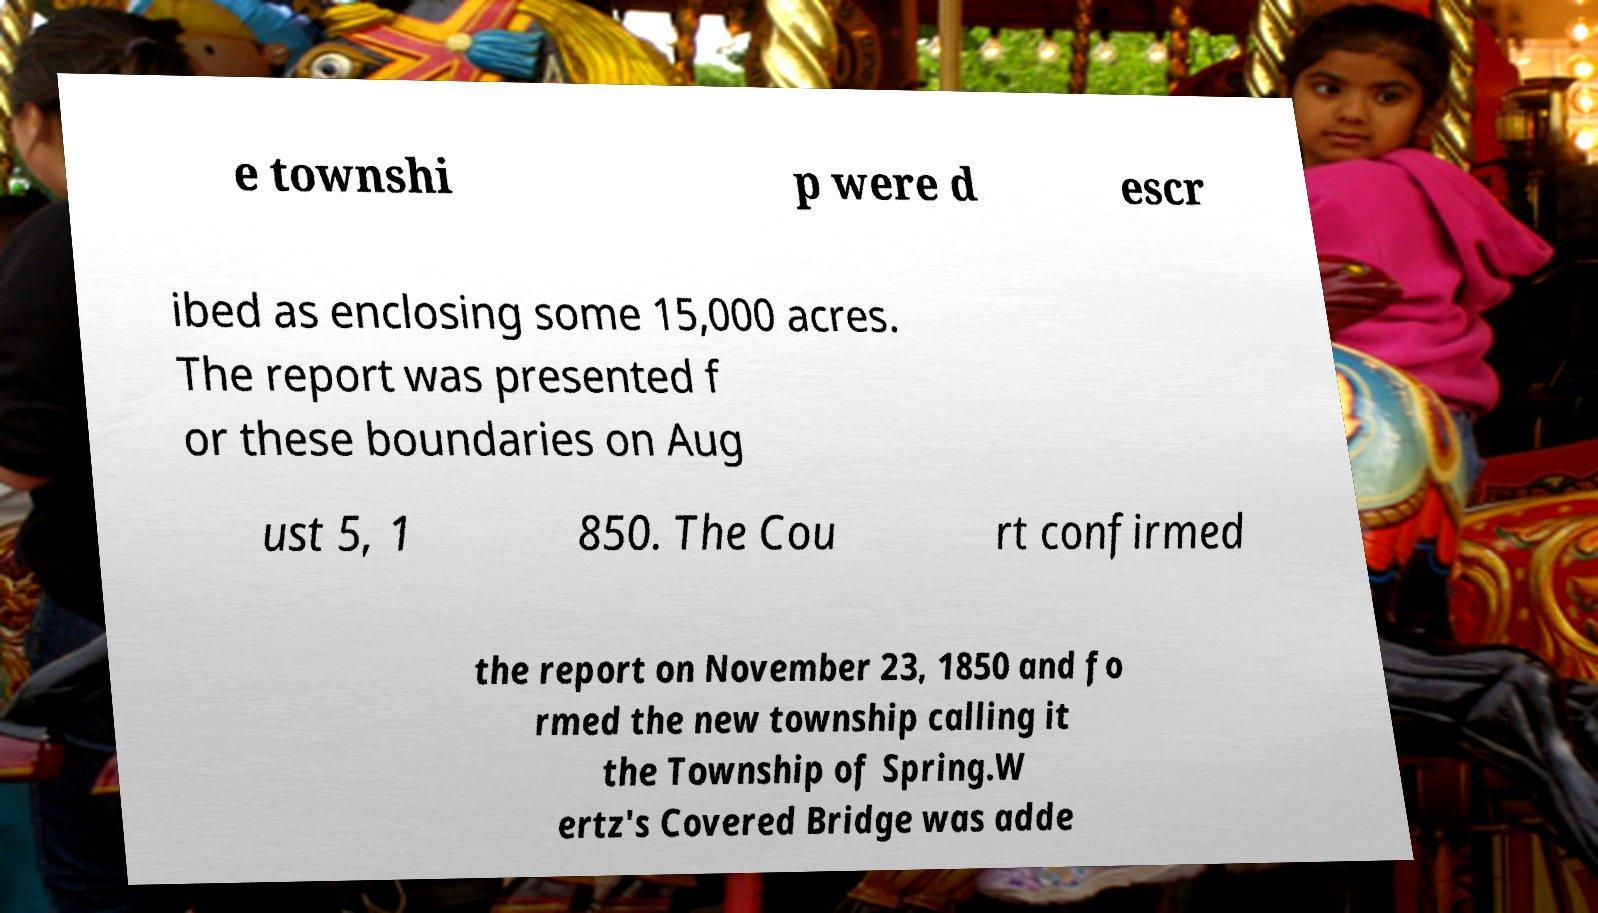There's text embedded in this image that I need extracted. Can you transcribe it verbatim? e townshi p were d escr ibed as enclosing some 15,000 acres. The report was presented f or these boundaries on Aug ust 5, 1 850. The Cou rt confirmed the report on November 23, 1850 and fo rmed the new township calling it the Township of Spring.W ertz's Covered Bridge was adde 